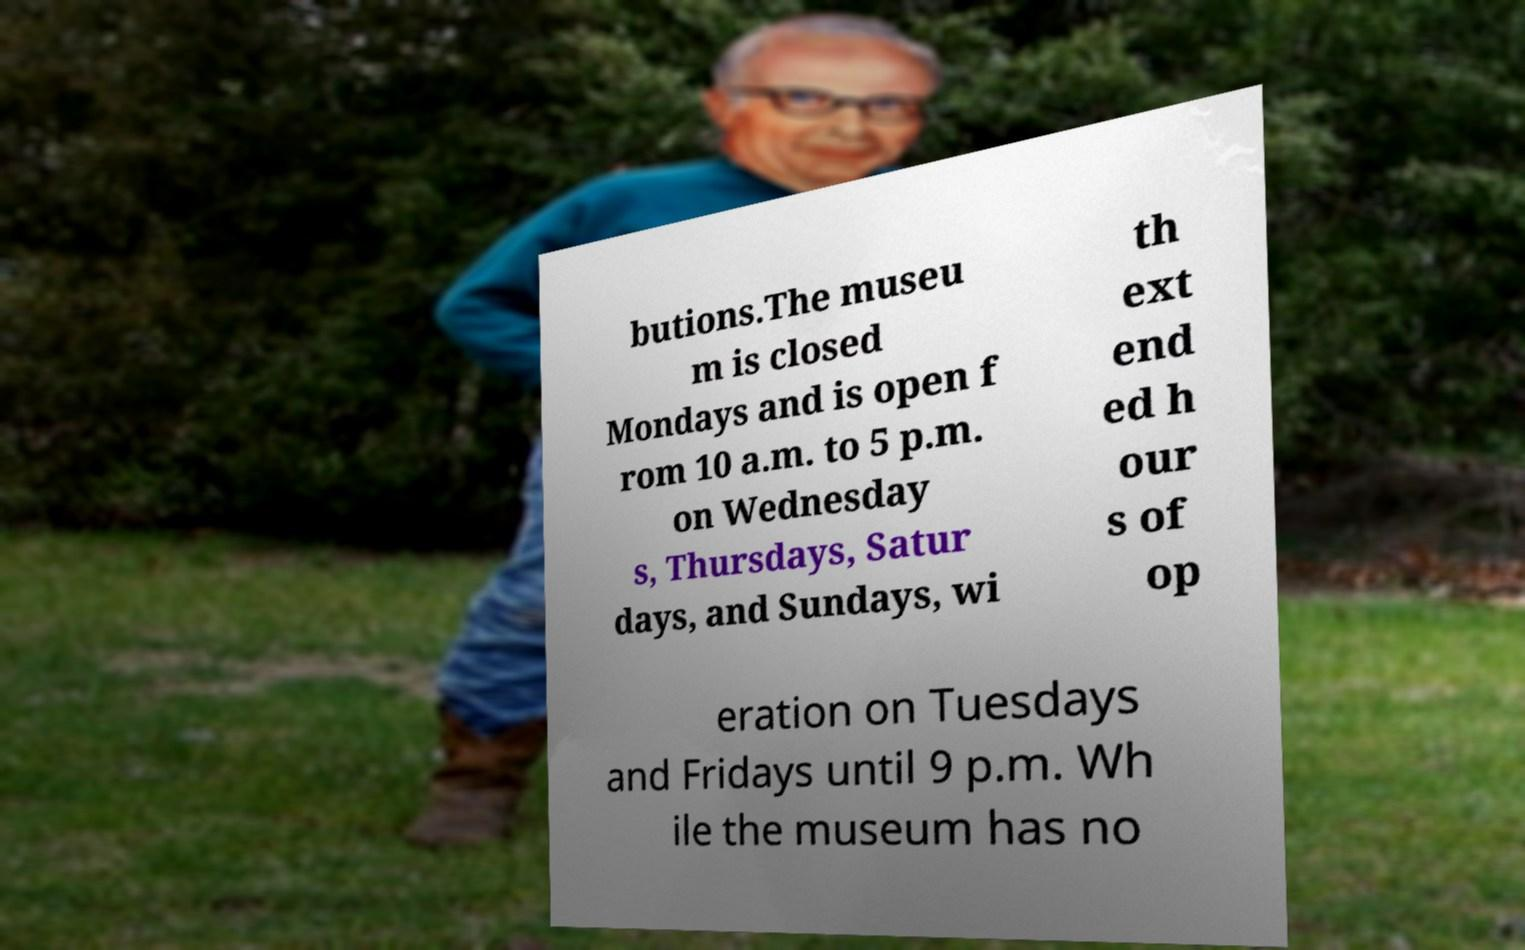I need the written content from this picture converted into text. Can you do that? butions.The museu m is closed Mondays and is open f rom 10 a.m. to 5 p.m. on Wednesday s, Thursdays, Satur days, and Sundays, wi th ext end ed h our s of op eration on Tuesdays and Fridays until 9 p.m. Wh ile the museum has no 